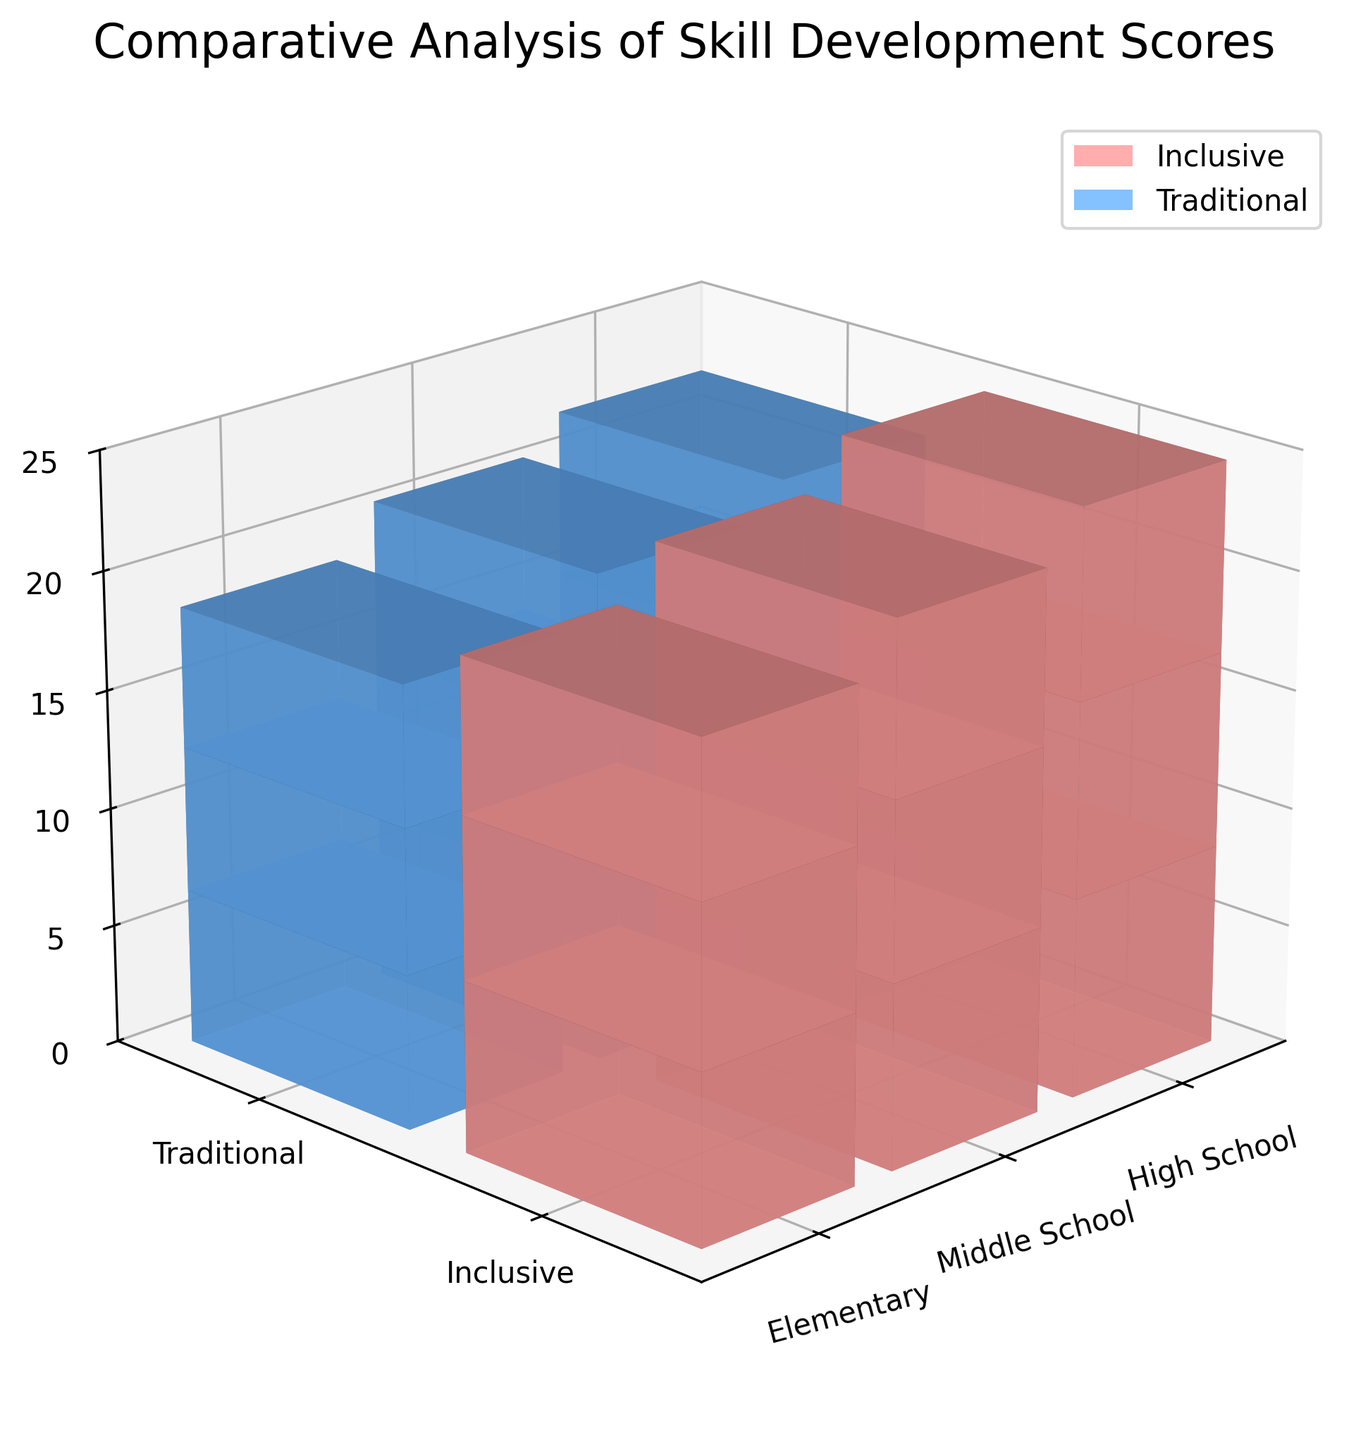What is the color representing the inclusive program? The figure uses color to differentiate between the program types. The legends indicate the inclusive program is represented by a pinkish color.
Answer: Pinkish Which grade level has the highest social skill score in the inclusive program? The highest social skill score for the inclusive program is seen at the high school level, indicated by the tallest pink bar in the social skill score segment.
Answer: High School By how much does the communication score for middle school students in the inclusive program exceed that of the traditional program? The communication score for middle school inclusive students is 7.3, whereas for traditional it is 6.6. The difference is 7.3 - 6.6 = 0.7.
Answer: 0.7 What is the total score (social skill, teamwork, and communication combined) for elementary students in the traditional program? Summing up the scores for elementary traditional is 6.5 (social skill) + 6.1 (teamwork) + 5.9 (communication) = 18.5.
Answer: 18.5 How do the teamwork scores for high school students compare between inclusive and traditional programs? The teamwork score for high school inclusive students is 8.2, while it is 7.3 for traditional students. The inclusive program has a higher teamwork score.
Answer: Inclusive > Traditional What is the average social skill score across all grade levels for the traditional program? The social skill scores for traditional programs are 6.5 (elementary), 7.1 (middle), and 7.6 (high school). The average is (6.5 + 7.1 + 7.6) / 3 = 7.07.
Answer: 7.07 Are communication scores generally higher in inclusive or traditional programs? By examining the bars, for each grade level, communication scores are consistently higher in the inclusive programs compared to traditional programs.
Answer: Inclusive What is the total height of all stacked segments for middle school students in the inclusive program? Adding the social skill, teamwork, and communication scores for middle school inclusive students: 7.8 + 7.5 + 7.3 = 22.6.
Answer: 22.6 Which grade level shows the least difference in teamwork scores between the inclusive and traditional programs? The difference in teamwork scores are 0.7 (elementary: 6.8 - 6.1), 0.7 (middle school: 7.5 - 6.8), and 0.9 (high school: 8.2 - 7.3). The least difference is seen at the elementary and middle school levels.
Answer: Elementary & Middle School 